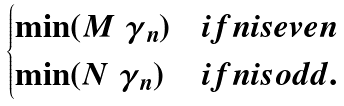Convert formula to latex. <formula><loc_0><loc_0><loc_500><loc_500>\begin{cases} \min ( M \ \gamma _ { n } ) & i f n i s e v e n \\ \min ( N \ \gamma _ { n } ) & i f n i s o d d . \end{cases}</formula> 